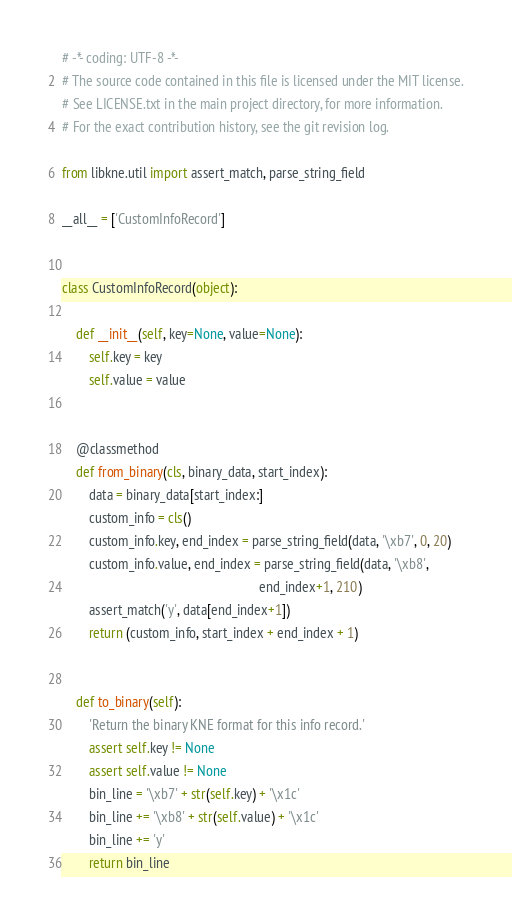Convert code to text. <code><loc_0><loc_0><loc_500><loc_500><_Python_># -*- coding: UTF-8 -*-
# The source code contained in this file is licensed under the MIT license.
# See LICENSE.txt in the main project directory, for more information.
# For the exact contribution history, see the git revision log.

from libkne.util import assert_match, parse_string_field

__all__ = ['CustomInfoRecord']


class CustomInfoRecord(object):
    
    def __init__(self, key=None, value=None):
        self.key = key
        self.value = value
    
    
    @classmethod
    def from_binary(cls, binary_data, start_index):
        data = binary_data[start_index:]
        custom_info = cls()
        custom_info.key, end_index = parse_string_field(data, '\xb7', 0, 20)
        custom_info.value, end_index = parse_string_field(data, '\xb8', 
                                                          end_index+1, 210)
        assert_match('y', data[end_index+1])
        return (custom_info, start_index + end_index + 1)
    
    
    def to_binary(self):
        'Return the binary KNE format for this info record.'
        assert self.key != None
        assert self.value != None
        bin_line = '\xb7' + str(self.key) + '\x1c'
        bin_line += '\xb8' + str(self.value) + '\x1c'
        bin_line += 'y'
        return bin_line

</code> 